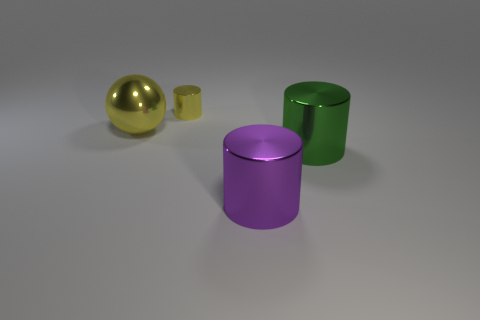Subtract all large cylinders. How many cylinders are left? 1 Add 4 yellow matte balls. How many objects exist? 8 Subtract all cylinders. How many objects are left? 1 Add 1 tiny metal things. How many tiny metal things exist? 2 Subtract 1 purple cylinders. How many objects are left? 3 Subtract all large green cubes. Subtract all large things. How many objects are left? 1 Add 3 big green metal cylinders. How many big green metal cylinders are left? 4 